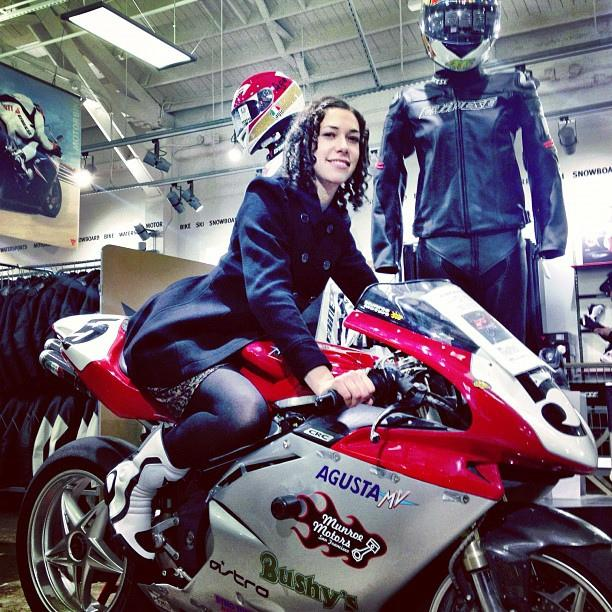What does the woman have on her feet? boots 